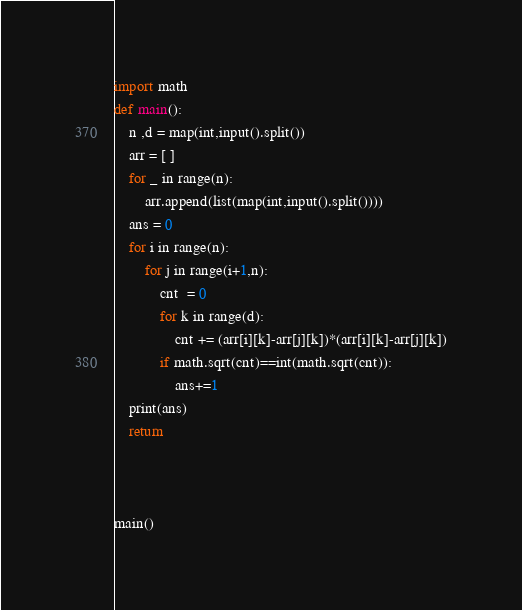Convert code to text. <code><loc_0><loc_0><loc_500><loc_500><_Python_>import math
def main():
	n ,d = map(int,input().split())
	arr = [ ]
	for _ in range(n):
		arr.append(list(map(int,input().split())))
	ans = 0
	for i in range(n):
		for j in range(i+1,n):
			cnt  = 0	
			for k in range(d):
				cnt += (arr[i][k]-arr[j][k])*(arr[i][k]-arr[j][k])
			if math.sqrt(cnt)==int(math.sqrt(cnt)):
				ans+=1
	print(ans)
	return



main()
</code> 